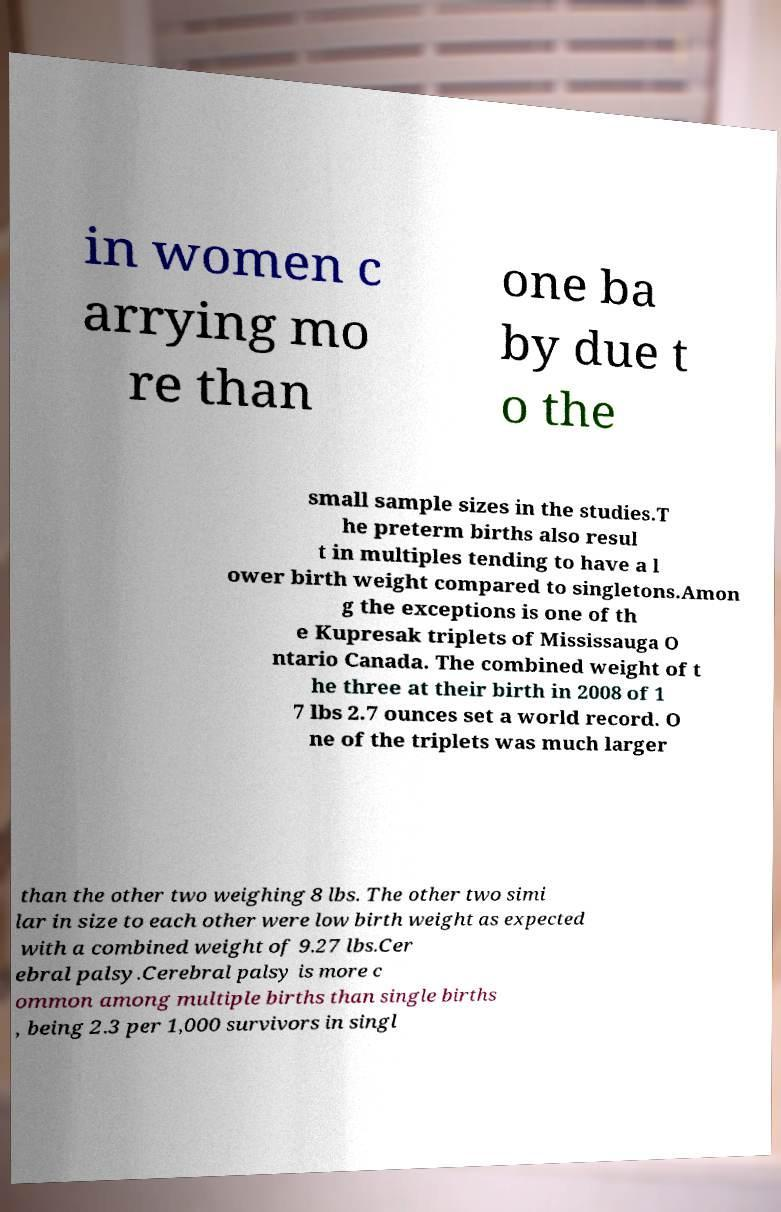Please read and relay the text visible in this image. What does it say? in women c arrying mo re than one ba by due t o the small sample sizes in the studies.T he preterm births also resul t in multiples tending to have a l ower birth weight compared to singletons.Amon g the exceptions is one of th e Kupresak triplets of Mississauga O ntario Canada. The combined weight of t he three at their birth in 2008 of 1 7 lbs 2.7 ounces set a world record. O ne of the triplets was much larger than the other two weighing 8 lbs. The other two simi lar in size to each other were low birth weight as expected with a combined weight of 9.27 lbs.Cer ebral palsy.Cerebral palsy is more c ommon among multiple births than single births , being 2.3 per 1,000 survivors in singl 